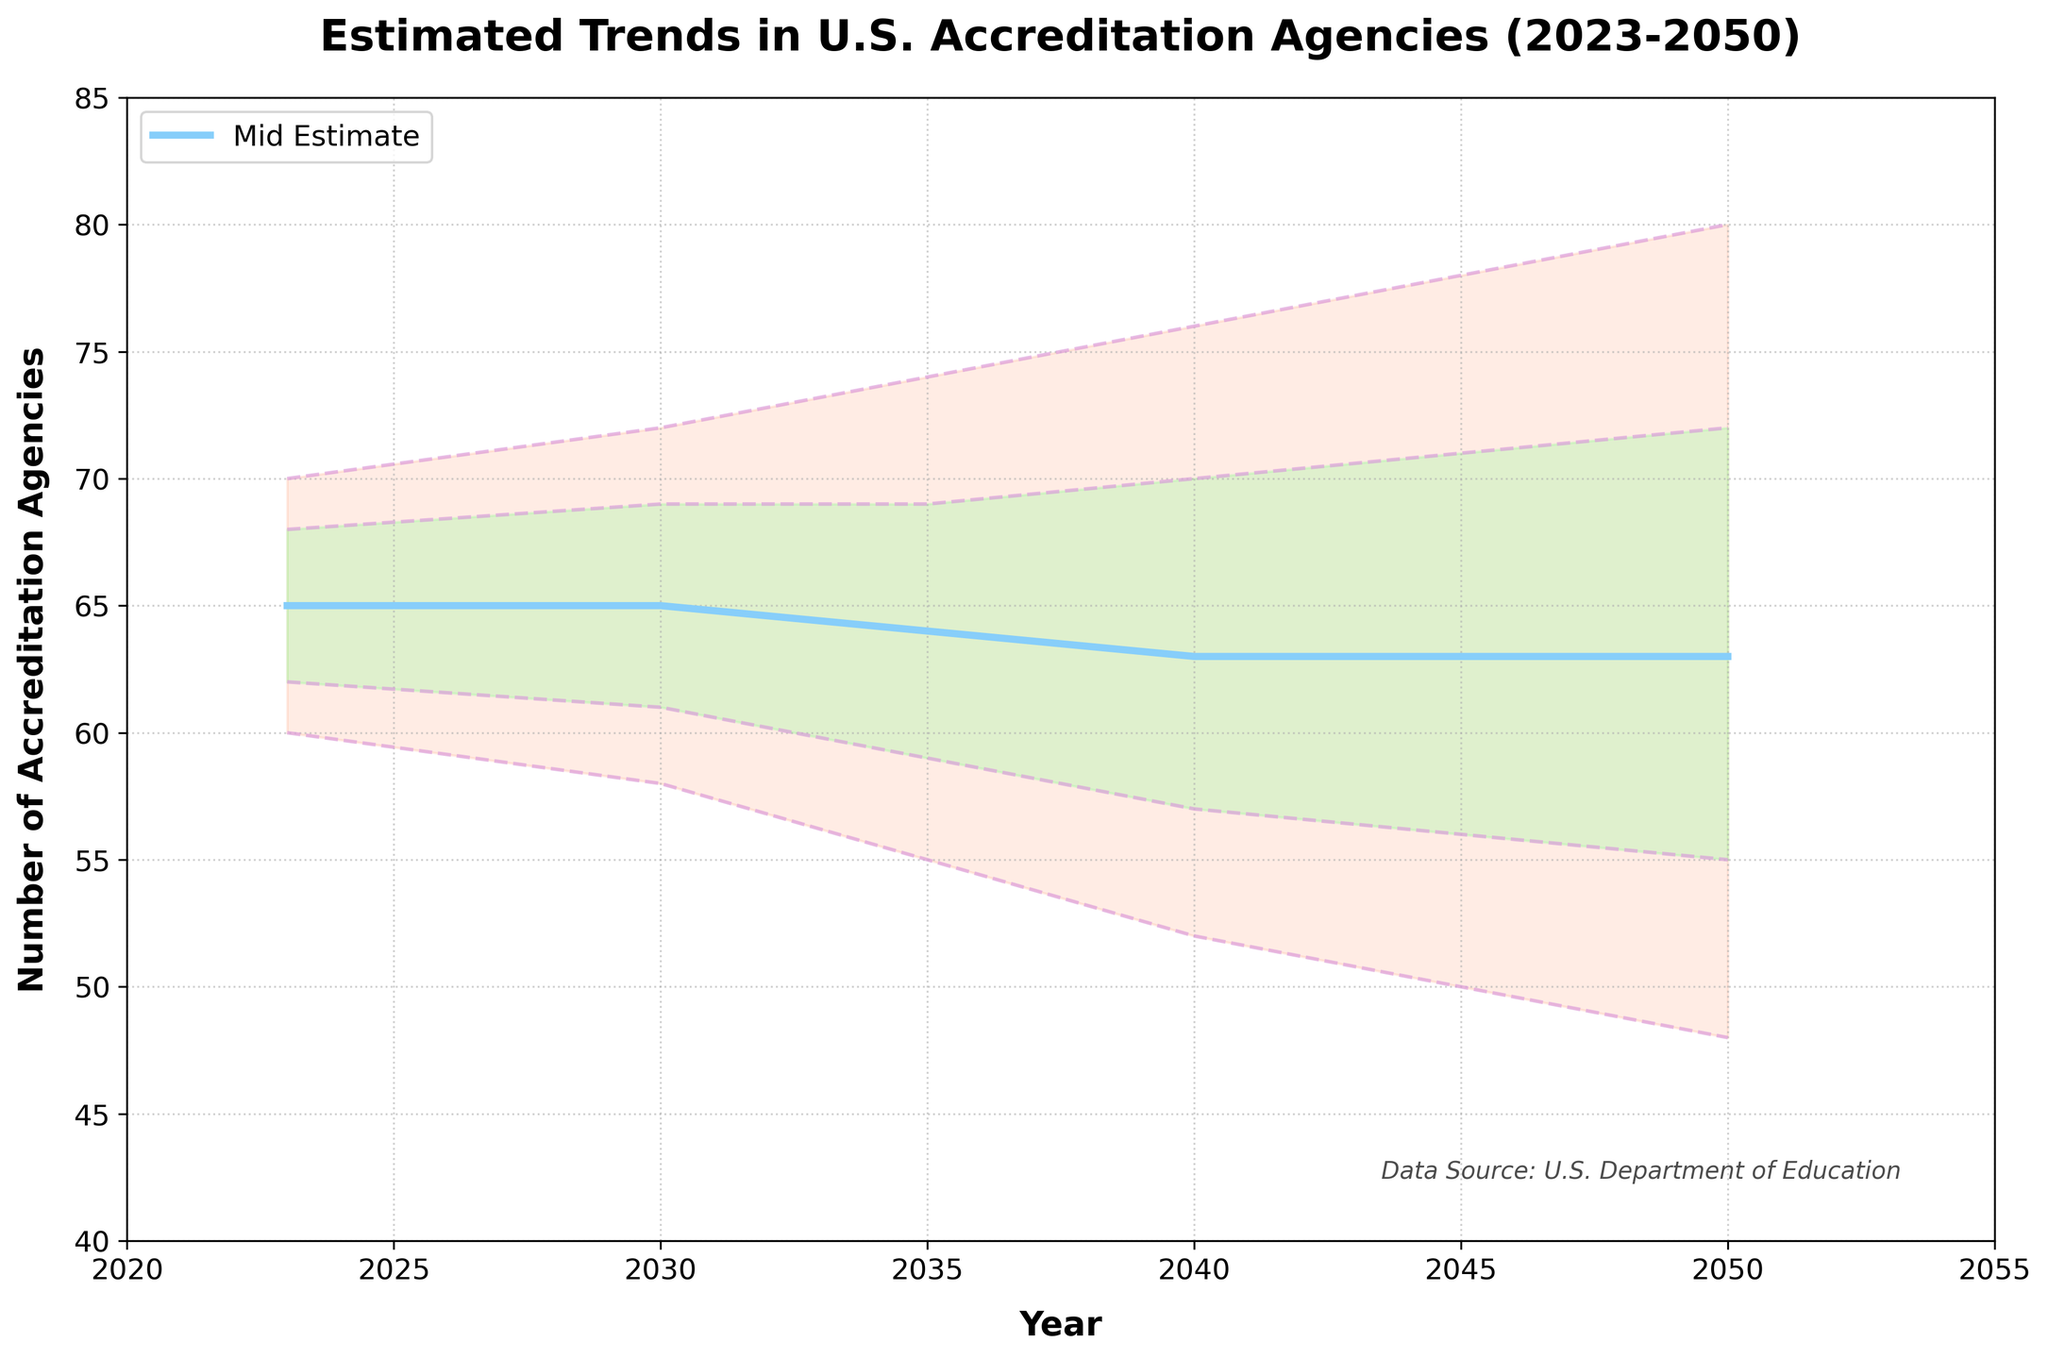what is the title of the figure? The title is prominently placed at the top and reads "Estimated Trends in U.S. Accreditation Agencies (2023-2050)"
Answer: Estimated Trends in U.S. Accreditation Agencies (2023-2050) How many ranges are shown in the fan chart? The chart displays five ranges: Low, Low-Mid, Mid, Mid-High, and High, highlighted with varying degrees of shading and line styles.
Answer: 5 What is the estimated number of accreditation agencies for the mid estimate in 2035? Locate the year 2035 on the x-axis and then trace the mid estimate line to its corresponding point on the y-axis, which is 64.
Answer: 64 What is the lowest estimate for the number of accreditation agencies in 2050? Find the year 2050 on the x-axis, then look at the lowest bound in the shaded area, which is 48.
Answer: 48 How does the mid estimate trend change from 2023 to 2050? Observe the mid estimate line from 2023 to 2050; it starts at 65 in 2023 and trends downward, reaching 63 in 2050.
Answer: Decreases from 65 to 63 What is the range for the number of accreditation agencies in 2040? For 2040, look at the shaded area; it ranges from the lowest projection of 52 to the highest projection of 76.
Answer: 52 to 76 In which year is the range between the Low-Mid and Mid-High estimates the narrowest? Compare the vertical distance between the Low-Mid and Mid-High lines for each year; the range appears narrowest around 2035.
Answer: 2035 What is the difference between the High estimate and Low estimate in 2045? Identify the values for the high (78) and low (50) estimates in 2045, then subtract the low estimate from the high estimate (78 - 50 = 28).
Answer: 28 Which estimate is always decreasing over the years? Examine each of the estimate lines (Low, Low-Mid, Mid, Mid-High, High) from 2023 to 2050; the Low estimate consistently decreases over this period.
Answer: Low estimate How does the High estimate in 2030 compare to the High estimate in 2050? Look at the values for the high estimates in 2030 (72) and 2050 (80); the high estimate increases from 72 to 80.
Answer: 2030: 72, 2050: 80 